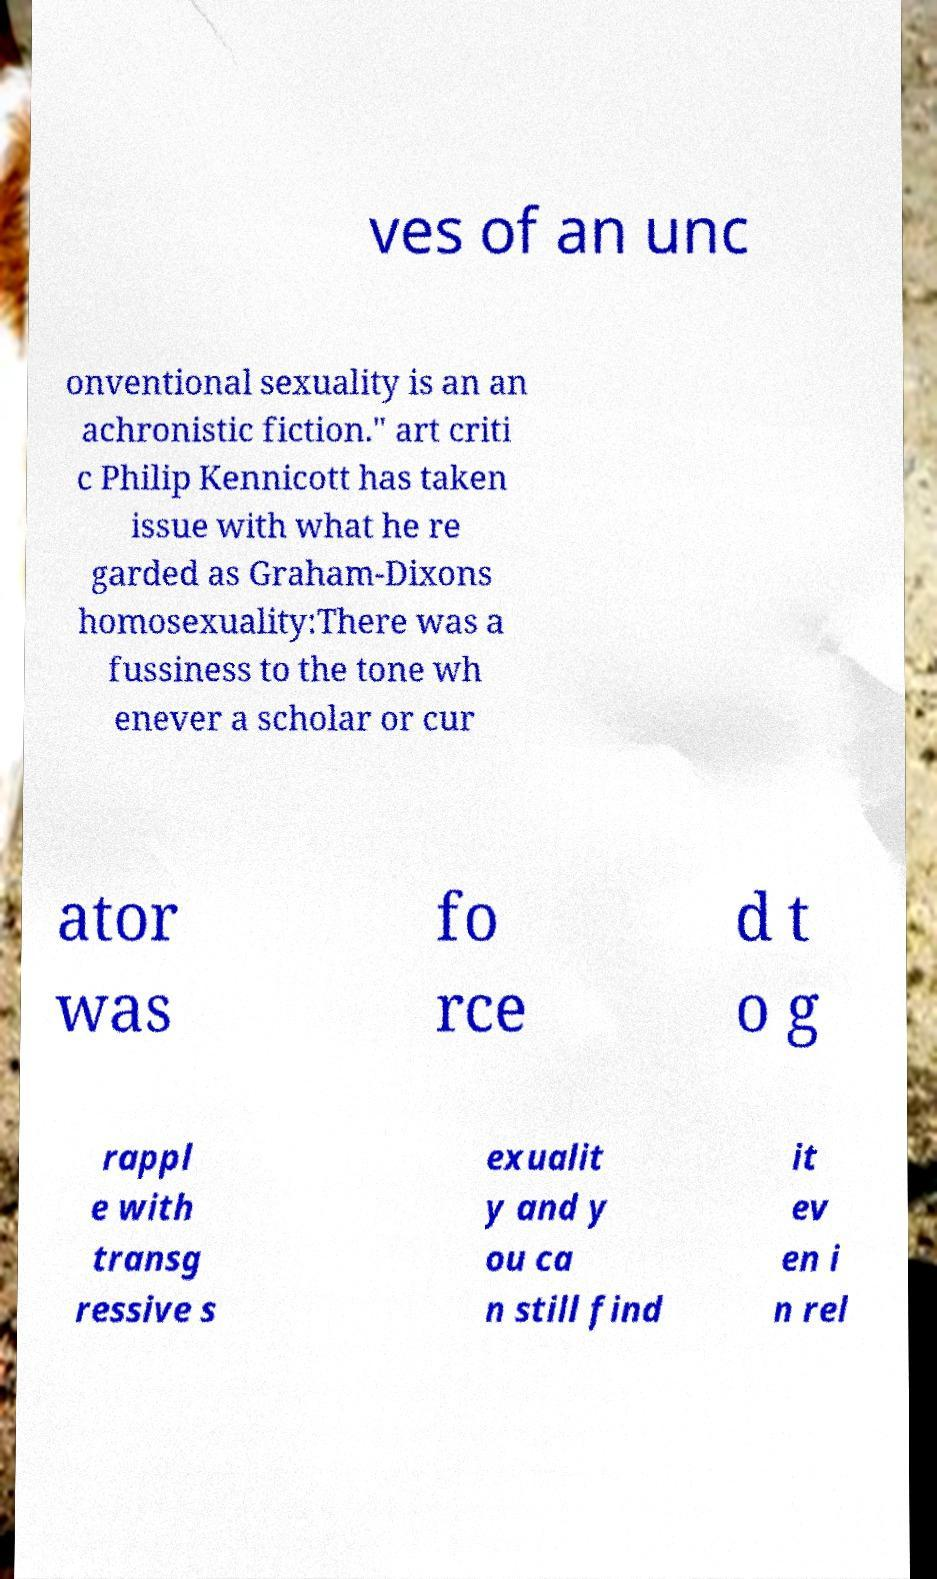For documentation purposes, I need the text within this image transcribed. Could you provide that? ves of an unc onventional sexuality is an an achronistic fiction." art criti c Philip Kennicott has taken issue with what he re garded as Graham-Dixons homosexuality:There was a fussiness to the tone wh enever a scholar or cur ator was fo rce d t o g rappl e with transg ressive s exualit y and y ou ca n still find it ev en i n rel 